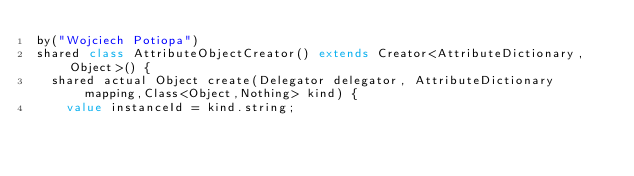<code> <loc_0><loc_0><loc_500><loc_500><_Ceylon_>by("Wojciech Potiopa")
shared class AttributeObjectCreator() extends Creator<AttributeDictionary,Object>() {
	shared actual Object create(Delegator delegator, AttributeDictionary mapping,Class<Object,Nothing> kind) {
		value instanceId = kind.string;</code> 